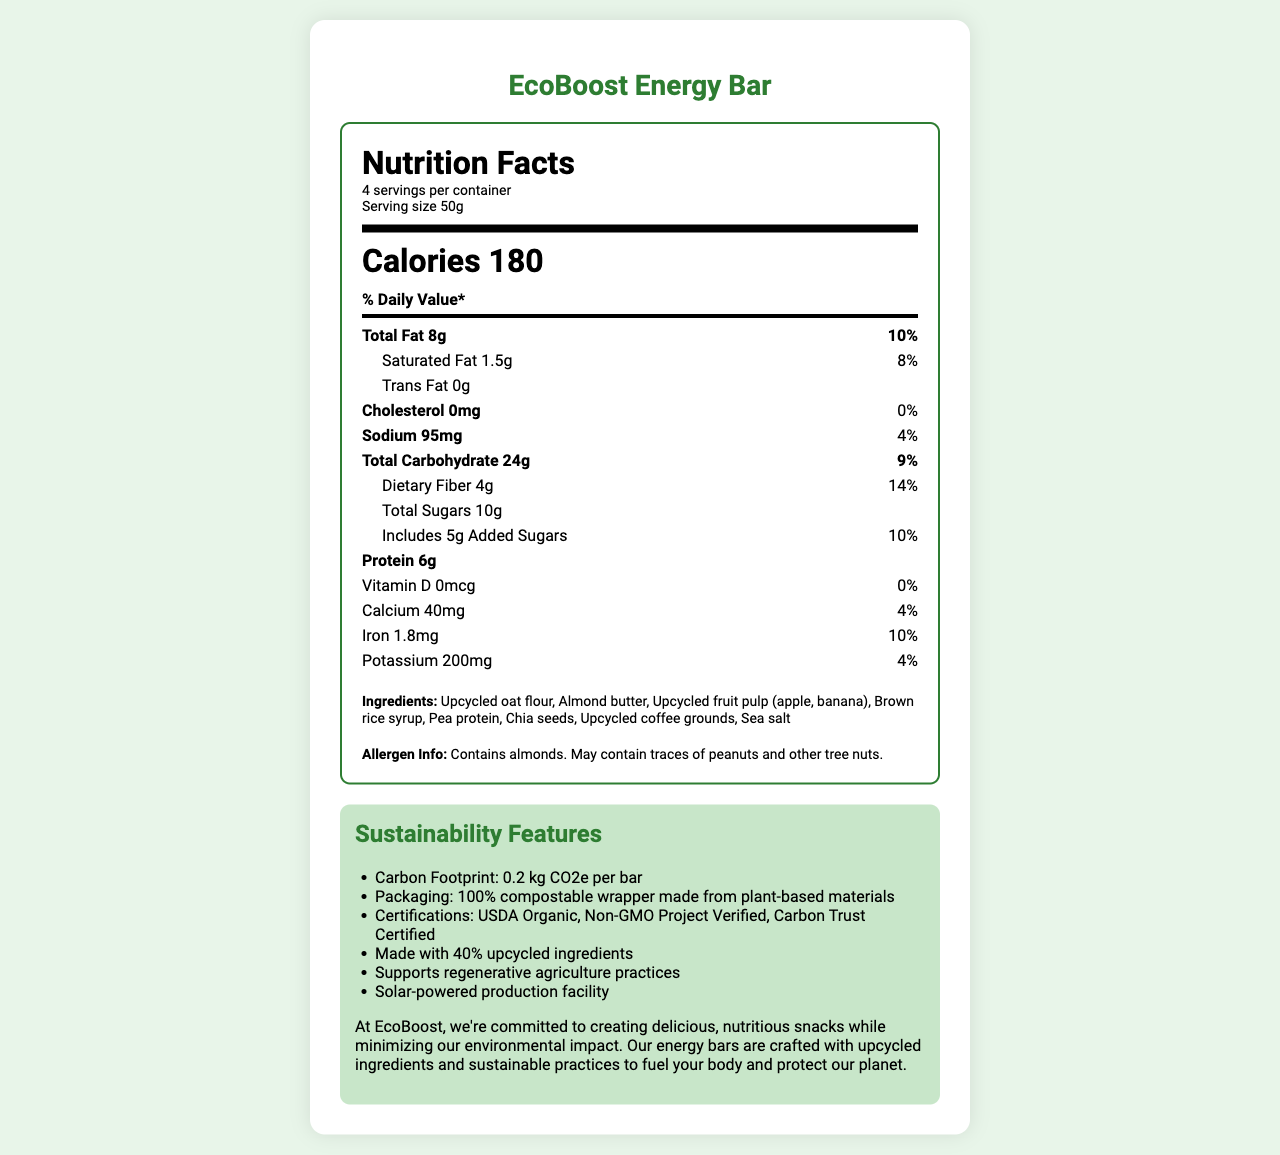How many servings are in the EcoBoost Energy Bar container? The serving information section at the top of the nutrition label indicates that there are 4 servings per container.
Answer: 4 servings per container What is the serving size of the EcoBoost Energy Bar? The serving information section at the top of the nutrition label indicates that the serving size is 50g.
Answer: 50g How many total calories are there per serving of the EcoBoost Energy Bar? The calories section of the nutrition label specifies that there are 180 calories per serving.
Answer: 180 calories What percentage of the daily value for dietary fiber does one serving of the EcoBoost Energy Bar provide? The section on dietary fiber shows that one serving provides 4g, which is 14% of the daily value.
Answer: 14% What types of certifications does the EcoBoost Energy Bar have? The sustainability features section lists the certifications the product has received.
Answer: USDA Organic, Non-GMO Project Verified, Carbon Trust Certified Which of the following is NOT an ingredient in the EcoBoost Energy Bar: A. Almond butter B. Pea protein C. Soy protein D. Chia seeds The ingredients section lists all the ingredients, and soy protein is not one of them.
Answer: C. Soy protein What is the carbon footprint per bar for the EcoBoost Energy Bar? A. 0.1 kg CO2e B. 0.2 kg CO2e C. 0.3 kg CO2e D. 0.4 kg CO2e The sustainability features section states that the carbon footprint is 0.2 kg CO2e per bar.
Answer: B. 0.2 kg CO2e Does the EcoBoost Energy Bar contain any cholesterol? The nutrition facts section shows that the cholesterol amount is 0mg, which is 0% of the daily value.
Answer: No Is the wrapper of the EcoBoost Energy Bar compostable? The sustainability features section mentions that the packaging is a 100% compostable wrapper made from plant-based materials.
Answer: Yes Describe the main idea of the EcoBoost Energy Bar's Nutrition Facts Label. The document provides detailed nutrition information, the ingredients list, allergen information, sustainability features, and certifications for the EcoBoost Energy Bar. It highlights the product’s low environmental impact and sustainable practices used in its production.
Answer: The EcoBoost Energy Bar is an eco-friendly product designed with nutrition and sustainability in mind. Each 50g serving contains 180 calories and various nutrients, including 6g of protein and 4g of dietary fiber. It is made from upcycled ingredients such as oat flour, fruit pulp, and coffee grounds and is certified USDA Organic, Non-GMO Project Verified, and Carbon Trust Certified. The product features a compostable wrapper and has a low carbon footprint of 0.2 kg CO2e per bar. The company emphasizes its commitment to environmental sustainability through practices like using a solar-powered production facility and supporting regenerative agriculture. How many grams of added sugars are in a serving of the EcoBoost Energy Bar? The nutrition facts section shows that there are 5g of added sugars in each serving.
Answer: 5g What is the daily value percentage for iron in the EcoBoost Energy Bar? The nutrition facts section indicates that one serving provides 1.8mg of iron, which is 10% of the daily value.
Answer: 10% Does the EcoBoost Energy Bar support regenerative agriculture practices? The sustainability features section explicitly states that the product supports regenerative agriculture practices.
Answer: Yes How many vitamins and minerals are listed on the EcoBoost Energy Bar’s Nutrition Facts Label? The nutrition facts section lists Vitamin D, Calcium, Iron, and Potassium, making a total of four vitamins and minerals.
Answer: 4 What is the main source of protein in the EcoBoost Energy Bar? The document lists several ingredients but does not specify which is the main source of protein. Multiple ingredients might contribute to the protein content.
Answer: Cannot be determined What is the amount of saturated fat per serving? The nutrition facts section states that there are 1.5g of saturated fat per serving.
Answer: 1.5g How many grams of total fat are in a serving of the EcoBoost Energy Bar? The nutrition facts section shows that there are 8g of total fat in each serving.
Answer: 8g What is the sodium content in one serving? The nutrition facts section states that each serving contains 95mg of sodium.
Answer: 95mg How much calcium is in one serving of the EcoBoost Energy Bar? The nutrition facts section indicates that each serving has 40mg of calcium.
Answer: 40mg Does the product contain any peanuts? The allergen info section states that the product contains almonds and may contain traces of peanuts and other tree nuts.
Answer: May contain traces of peanuts 